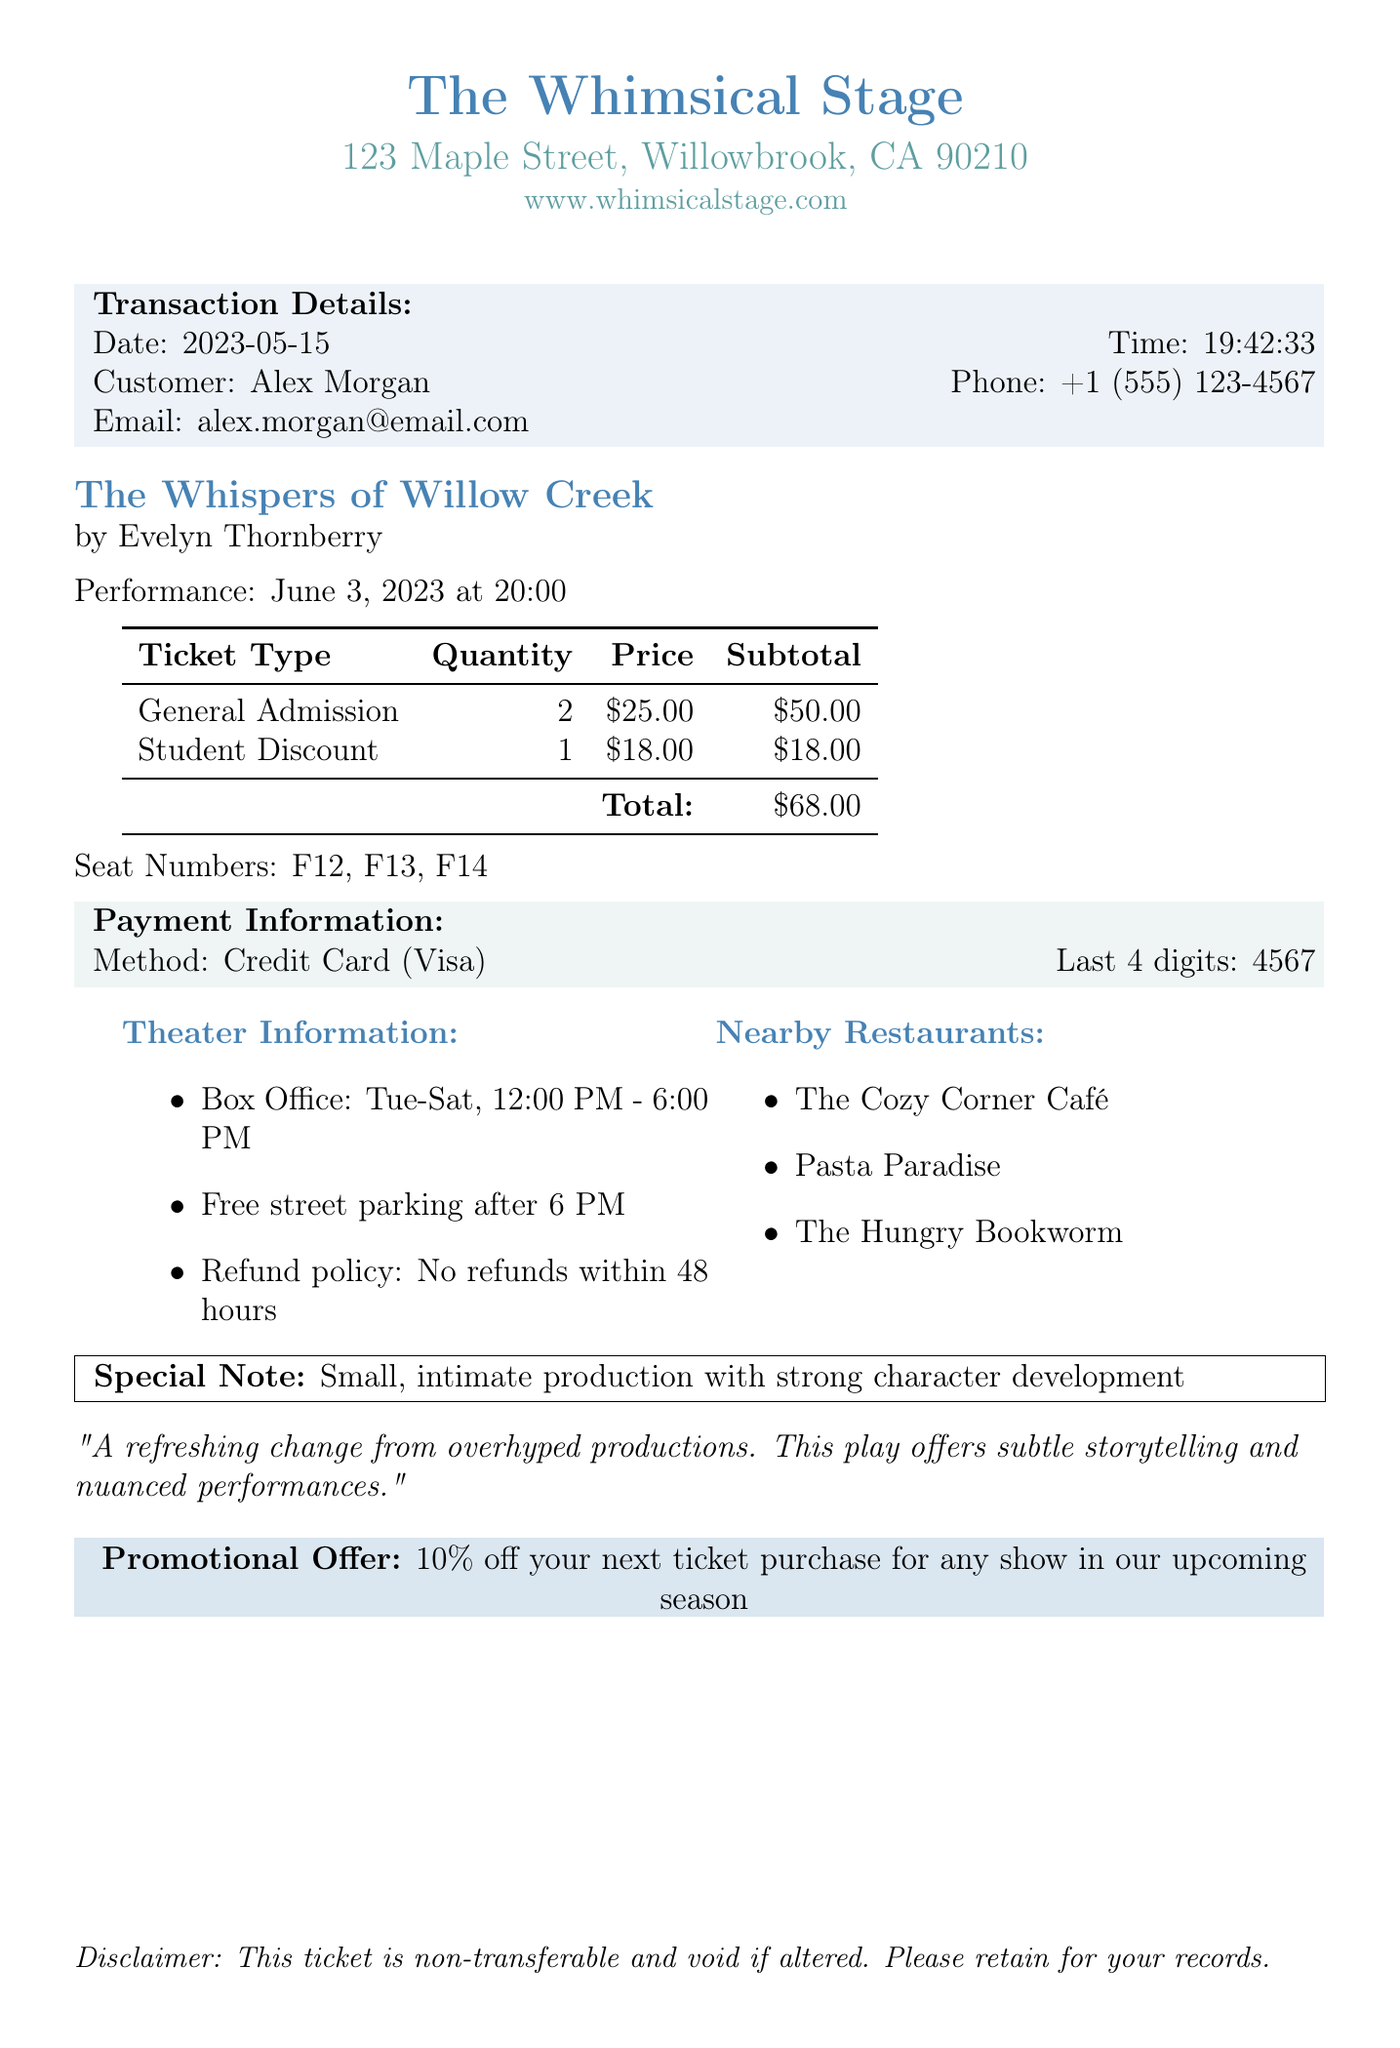What is the theater's name? The theater's name is prominently displayed at the top of the document.
Answer: The Whimsical Stage Who is the playwright of the play? The playwright's name is specified in the document under the play title.
Answer: Evelyn Thornberry What is the total amount paid for the tickets? The total amount is calculated from the ticket types listed in the document.
Answer: $68.00 On what date is the performance scheduled? The performance date is mentioned clearly in the document.
Answer: June 3, 2023 What is the method of payment used? The document specifies the method of payment in the payment section.
Answer: Credit Card How many General Admission tickets were purchased? The quantity of General Admission tickets is listed in the ticket types.
Answer: 2 What is the refund policy stated in the document? The refund policy is described within the theater information section.
Answer: No refunds within 48 hours of performance What promotional offer is available? The promotional offer is noted in the document as it relates to future purchases.
Answer: 10% off your next ticket purchase for any show in our upcoming season Which seat numbers were assigned? The assigned seat numbers are listed in the document details.
Answer: F12, F13, F14 